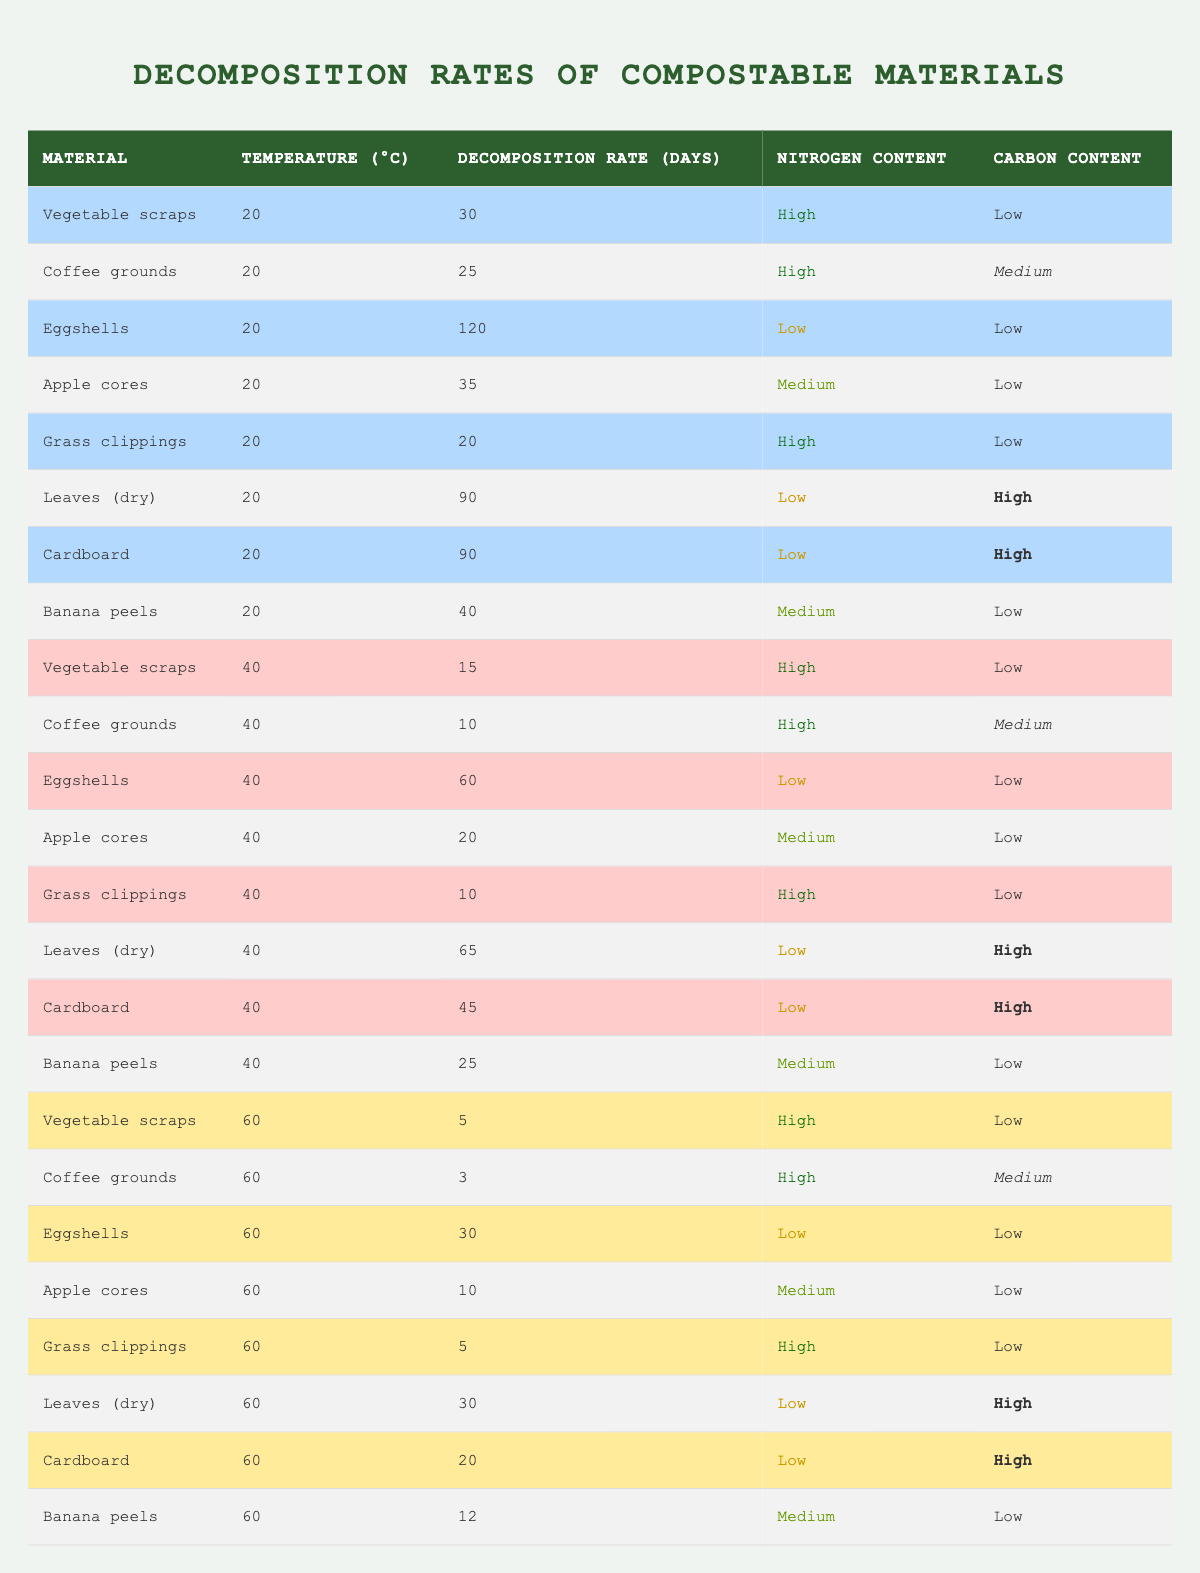What is the decomposition rate for vegetable scraps at 20°C? Referring to the table, vegetable scraps at 20°C have a decomposition rate of 30 days.
Answer: 30 days Which material has the shortest decomposition rate at 60°C? The table shows that coffee grounds have the shortest decomposition rate at 60°C, which is 3 days.
Answer: 3 days What is the average decomposition rate of eggshells across all temperatures? The decomposition rates for eggshells are 120 (at 20°C), 60 (at 40°C), and 30 (at 60°C). Adding these gives 210, and dividing by 3 results in an average of 70 days.
Answer: 70 days Is the nitrogen content of coffee grounds consistently high across all temperatures? Yes, the nitrogen content for coffee grounds is high at both 20°C, 40°C, and 60°C according to the table.
Answer: Yes At which temperature does grass clippings decompose the fastest? Looking at the table, grass clippings decompose the fastest at 60°C in 5 days, compared to 20°C (20 days) and 40°C (10 days).
Answer: 60°C How much longer do eggshells take to decompose at 20°C compared to 40°C? At 20°C, eggshells take 120 days to decompose, while at 40°C they take 60 days. The difference is 120 - 60 = 60 days.
Answer: 60 days Among all materials, which one has the highest decomposition rate at 40°C? By checking the table for decomposition rates at 40°C, eggshells take 60 days, and that is the highest among the listed materials at that temperature.
Answer: 60 days Are there any materials with low nitrogen and high carbon contents at 20°C? Yes, both leaves (dry) and cardboard have low nitrogen and high carbon contents at 20°C according to the table.
Answer: Yes What is the median decomposition rate for banana peels across the three temperatures? The decomposition rates for banana peels are 40 days (20°C), 25 days (40°C), and 12 days (60°C). When arranged in order (12, 25, 40), the median is 25 days.
Answer: 25 days How does the decomposition rate of vegetable scraps at 40°C compare to that at 20°C? The decomposition rate of vegetable scraps at 40°C is 15 days, which is significantly lower than the 30 days at 20°C, indicating it decomposes faster at higher temperatures.
Answer: Faster at 40°C 